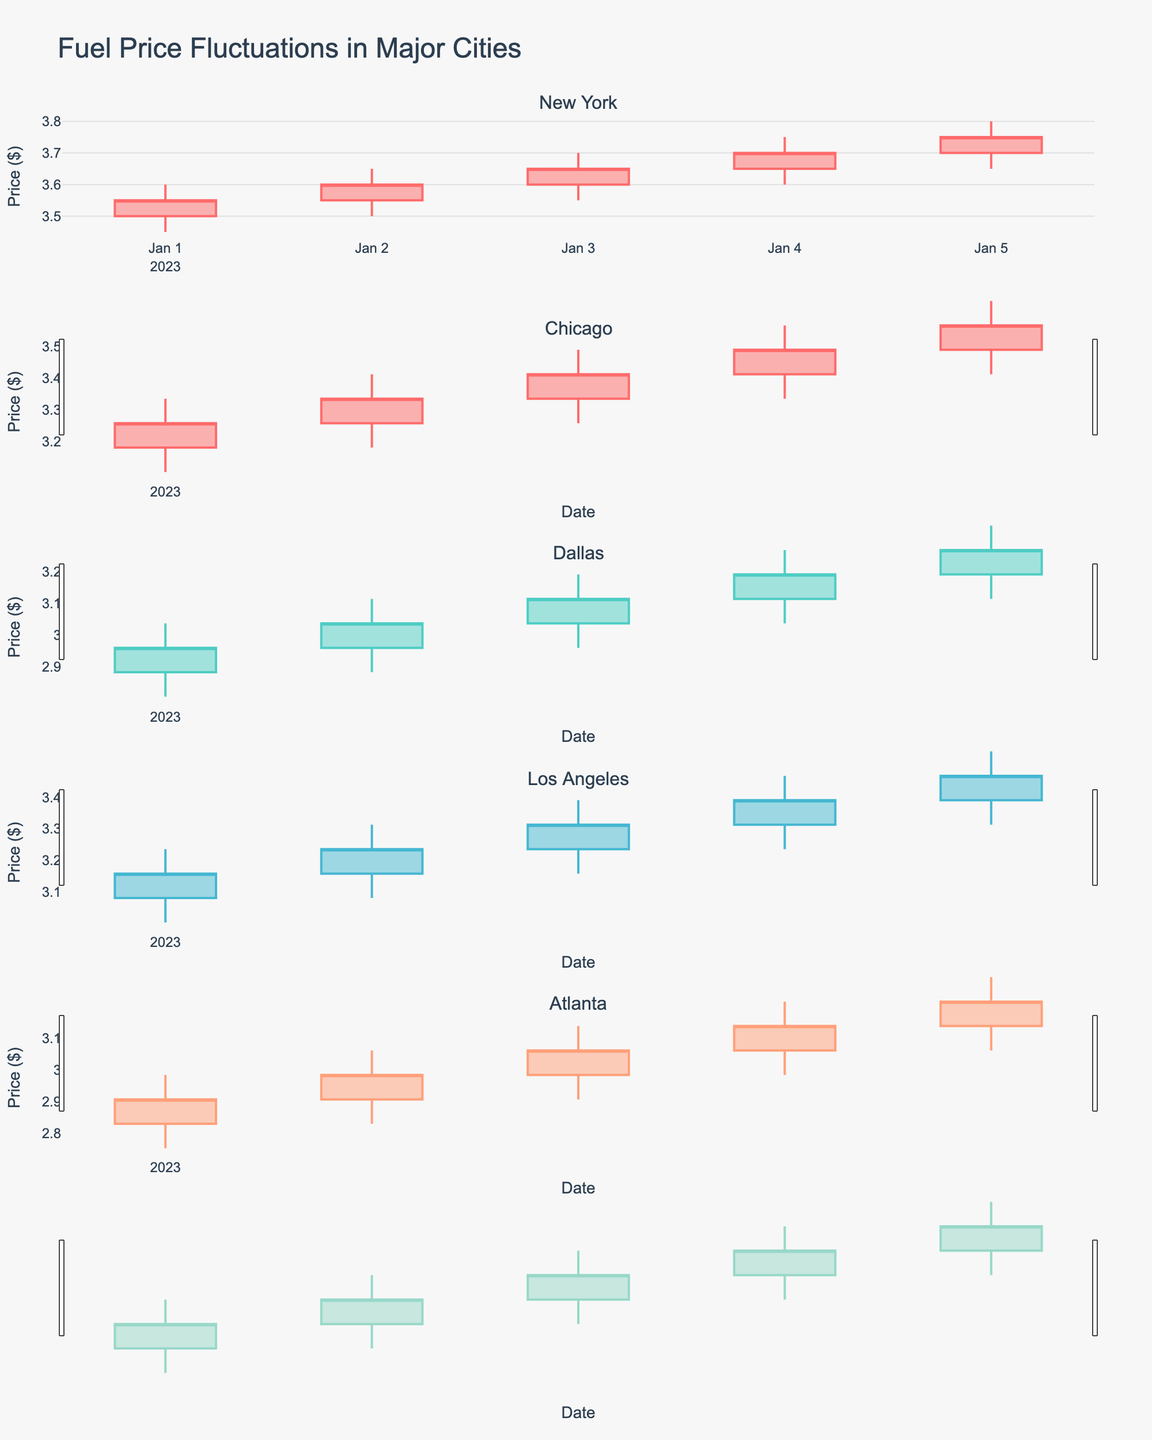what is the title of the plot? The title is displayed at the top center of the plot and provides a summary of what the plot is showing.
Answer: Fuel Price Fluctuations in Major Cities How many cities are displayed in the plot? The number of subplots vertically stacked in the plot corresponds to the number of cities.
Answer: 5 Which city had the highest fuel price on January 4th? Compare the high prices for January 4th across each city's subplot.
Answer: New York Which city had the lowest fuel price on January 1st? Compare the low prices for January 1st across each city's subplot.
Answer: Atlanta By how much did the closing price in Dallas change from January 1st to January 5th? Subtract the closing price of January 1st from the closing price of January 5th for Dallas. 3.15 - 2.95 = 0.20
Answer: 0.20 Which city shows the most consistent increase in fuel prices over the given period? Observe the trend in the closing prices for each city. The city with a consistent upward trend has the most consistent increase.
Answer: New York What is the range of fuel prices in Chicago on January 3rd? Subtract the low price from the high price on January 3rd in the Chicago subplot. 3.40 - 3.25 = 0.15
Answer: 0.15 Compare the highest fuel prices between Los Angeles and Dallas on January 2nd. Which city had a higher price, and by how much? Look at the high price for January 2nd in both subplots and subtract the lower from the higher. 3.25 - 3.05 = 0.20
Answer: Los Angeles by 0.20 Identify a day when fuel prices decreased in New York. Provide the specific date and the price change. Look for a date where the closing price is lower than the opening price in New York's subplot and calculate the difference. January 2nd, 3.60 - 3.55 = 0.05
Answer: January 2nd, 0.05 